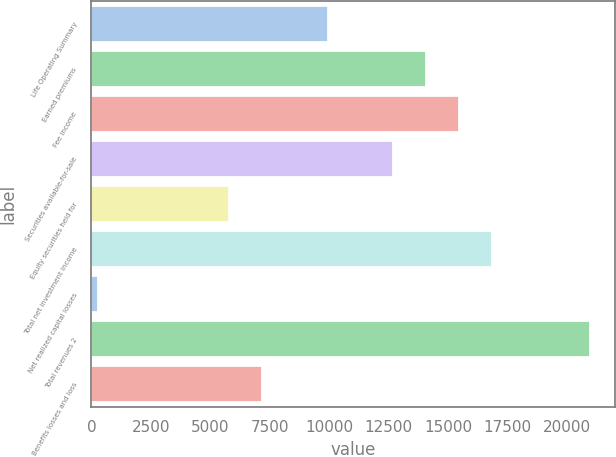Convert chart. <chart><loc_0><loc_0><loc_500><loc_500><bar_chart><fcel>Life Operating Summary<fcel>Earned premiums<fcel>Fee income<fcel>Securities available-for-sale<fcel>Equity securities held for<fcel>Total net investment income<fcel>Net realized capital losses<fcel>Total revenues 2<fcel>Benefits losses and loss<nl><fcel>9922.8<fcel>14064<fcel>15444.4<fcel>12683.6<fcel>5781.6<fcel>16824.8<fcel>260<fcel>20966<fcel>7162<nl></chart> 